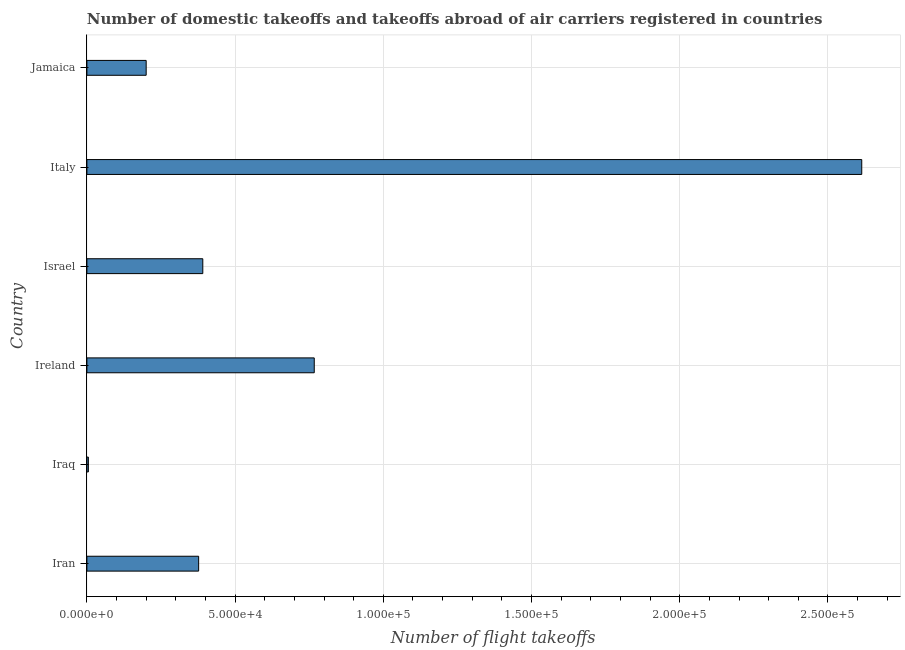Does the graph contain any zero values?
Your answer should be very brief. No. What is the title of the graph?
Offer a terse response. Number of domestic takeoffs and takeoffs abroad of air carriers registered in countries. What is the label or title of the X-axis?
Provide a succinct answer. Number of flight takeoffs. What is the number of flight takeoffs in Italy?
Your answer should be very brief. 2.61e+05. Across all countries, what is the maximum number of flight takeoffs?
Give a very brief answer. 2.61e+05. In which country was the number of flight takeoffs maximum?
Offer a very short reply. Italy. In which country was the number of flight takeoffs minimum?
Keep it short and to the point. Iraq. What is the sum of the number of flight takeoffs?
Offer a terse response. 4.35e+05. What is the difference between the number of flight takeoffs in Iran and Jamaica?
Your answer should be compact. 1.77e+04. What is the average number of flight takeoffs per country?
Keep it short and to the point. 7.26e+04. What is the median number of flight takeoffs?
Offer a very short reply. 3.84e+04. What is the ratio of the number of flight takeoffs in Israel to that in Jamaica?
Offer a terse response. 1.96. What is the difference between the highest and the second highest number of flight takeoffs?
Ensure brevity in your answer.  1.85e+05. What is the difference between the highest and the lowest number of flight takeoffs?
Your answer should be very brief. 2.61e+05. How many bars are there?
Your response must be concise. 6. Are all the bars in the graph horizontal?
Provide a short and direct response. Yes. What is the difference between two consecutive major ticks on the X-axis?
Make the answer very short. 5.00e+04. What is the Number of flight takeoffs in Iran?
Provide a short and direct response. 3.77e+04. What is the Number of flight takeoffs in Ireland?
Give a very brief answer. 7.67e+04. What is the Number of flight takeoffs in Israel?
Ensure brevity in your answer.  3.91e+04. What is the Number of flight takeoffs in Italy?
Provide a short and direct response. 2.61e+05. What is the difference between the Number of flight takeoffs in Iran and Iraq?
Your response must be concise. 3.72e+04. What is the difference between the Number of flight takeoffs in Iran and Ireland?
Offer a very short reply. -3.90e+04. What is the difference between the Number of flight takeoffs in Iran and Israel?
Your answer should be compact. -1400. What is the difference between the Number of flight takeoffs in Iran and Italy?
Offer a very short reply. -2.24e+05. What is the difference between the Number of flight takeoffs in Iran and Jamaica?
Provide a succinct answer. 1.77e+04. What is the difference between the Number of flight takeoffs in Iraq and Ireland?
Your response must be concise. -7.62e+04. What is the difference between the Number of flight takeoffs in Iraq and Israel?
Your answer should be very brief. -3.86e+04. What is the difference between the Number of flight takeoffs in Iraq and Italy?
Give a very brief answer. -2.61e+05. What is the difference between the Number of flight takeoffs in Iraq and Jamaica?
Provide a succinct answer. -1.95e+04. What is the difference between the Number of flight takeoffs in Ireland and Israel?
Your response must be concise. 3.76e+04. What is the difference between the Number of flight takeoffs in Ireland and Italy?
Your answer should be compact. -1.85e+05. What is the difference between the Number of flight takeoffs in Ireland and Jamaica?
Offer a terse response. 5.67e+04. What is the difference between the Number of flight takeoffs in Israel and Italy?
Make the answer very short. -2.22e+05. What is the difference between the Number of flight takeoffs in Israel and Jamaica?
Your answer should be very brief. 1.91e+04. What is the difference between the Number of flight takeoffs in Italy and Jamaica?
Ensure brevity in your answer.  2.41e+05. What is the ratio of the Number of flight takeoffs in Iran to that in Iraq?
Your response must be concise. 75.4. What is the ratio of the Number of flight takeoffs in Iran to that in Ireland?
Give a very brief answer. 0.49. What is the ratio of the Number of flight takeoffs in Iran to that in Italy?
Keep it short and to the point. 0.14. What is the ratio of the Number of flight takeoffs in Iran to that in Jamaica?
Your response must be concise. 1.89. What is the ratio of the Number of flight takeoffs in Iraq to that in Ireland?
Provide a succinct answer. 0.01. What is the ratio of the Number of flight takeoffs in Iraq to that in Israel?
Give a very brief answer. 0.01. What is the ratio of the Number of flight takeoffs in Iraq to that in Italy?
Your response must be concise. 0. What is the ratio of the Number of flight takeoffs in Iraq to that in Jamaica?
Make the answer very short. 0.03. What is the ratio of the Number of flight takeoffs in Ireland to that in Israel?
Keep it short and to the point. 1.96. What is the ratio of the Number of flight takeoffs in Ireland to that in Italy?
Offer a very short reply. 0.29. What is the ratio of the Number of flight takeoffs in Ireland to that in Jamaica?
Your answer should be very brief. 3.83. What is the ratio of the Number of flight takeoffs in Israel to that in Jamaica?
Provide a short and direct response. 1.96. What is the ratio of the Number of flight takeoffs in Italy to that in Jamaica?
Your answer should be compact. 13.07. 